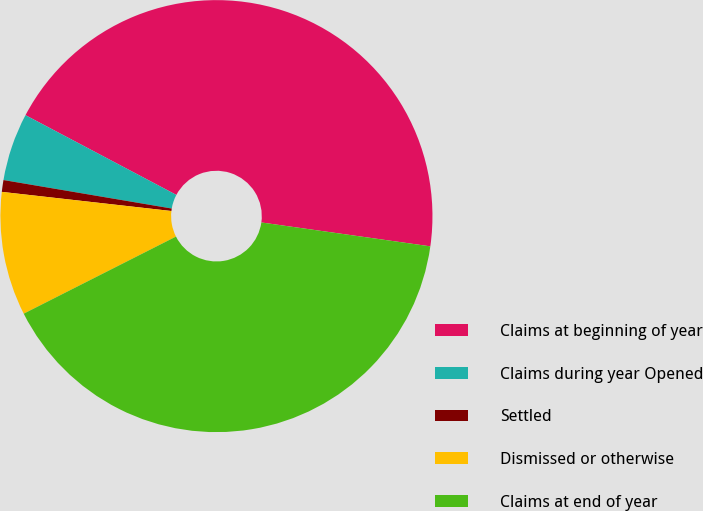<chart> <loc_0><loc_0><loc_500><loc_500><pie_chart><fcel>Claims at beginning of year<fcel>Claims during year Opened<fcel>Settled<fcel>Dismissed or otherwise<fcel>Claims at end of year<nl><fcel>44.5%<fcel>5.07%<fcel>0.88%<fcel>9.25%<fcel>40.31%<nl></chart> 